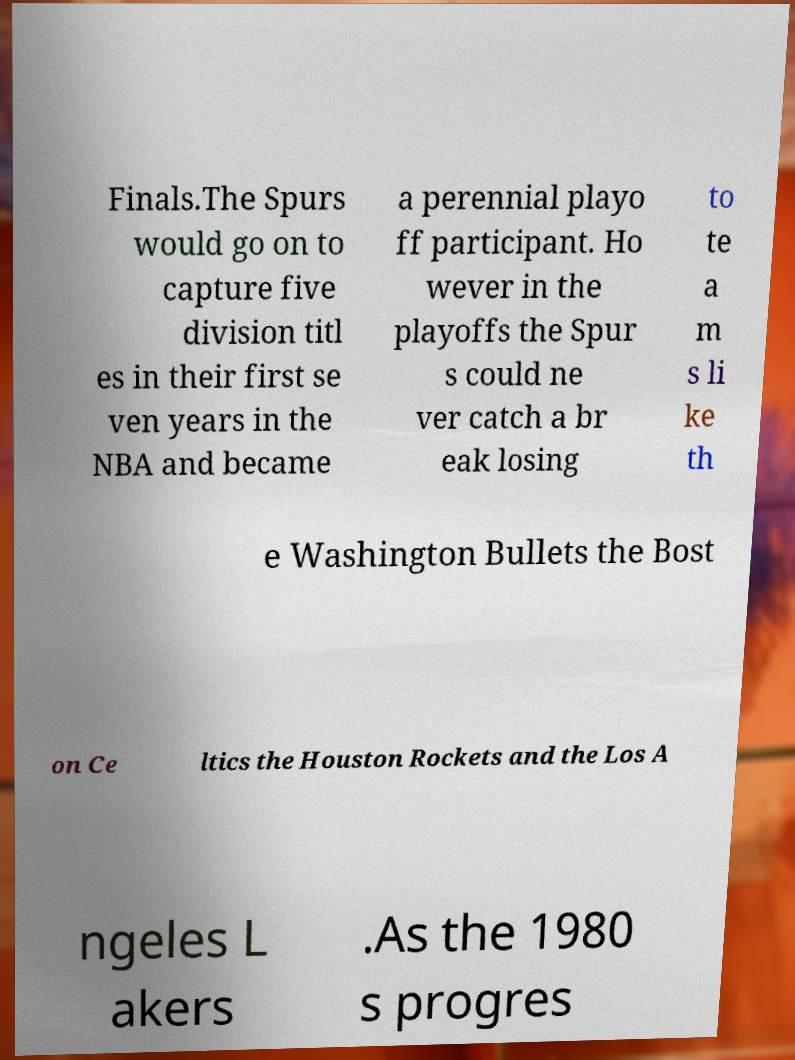For documentation purposes, I need the text within this image transcribed. Could you provide that? Finals.The Spurs would go on to capture five division titl es in their first se ven years in the NBA and became a perennial playo ff participant. Ho wever in the playoffs the Spur s could ne ver catch a br eak losing to te a m s li ke th e Washington Bullets the Bost on Ce ltics the Houston Rockets and the Los A ngeles L akers .As the 1980 s progres 